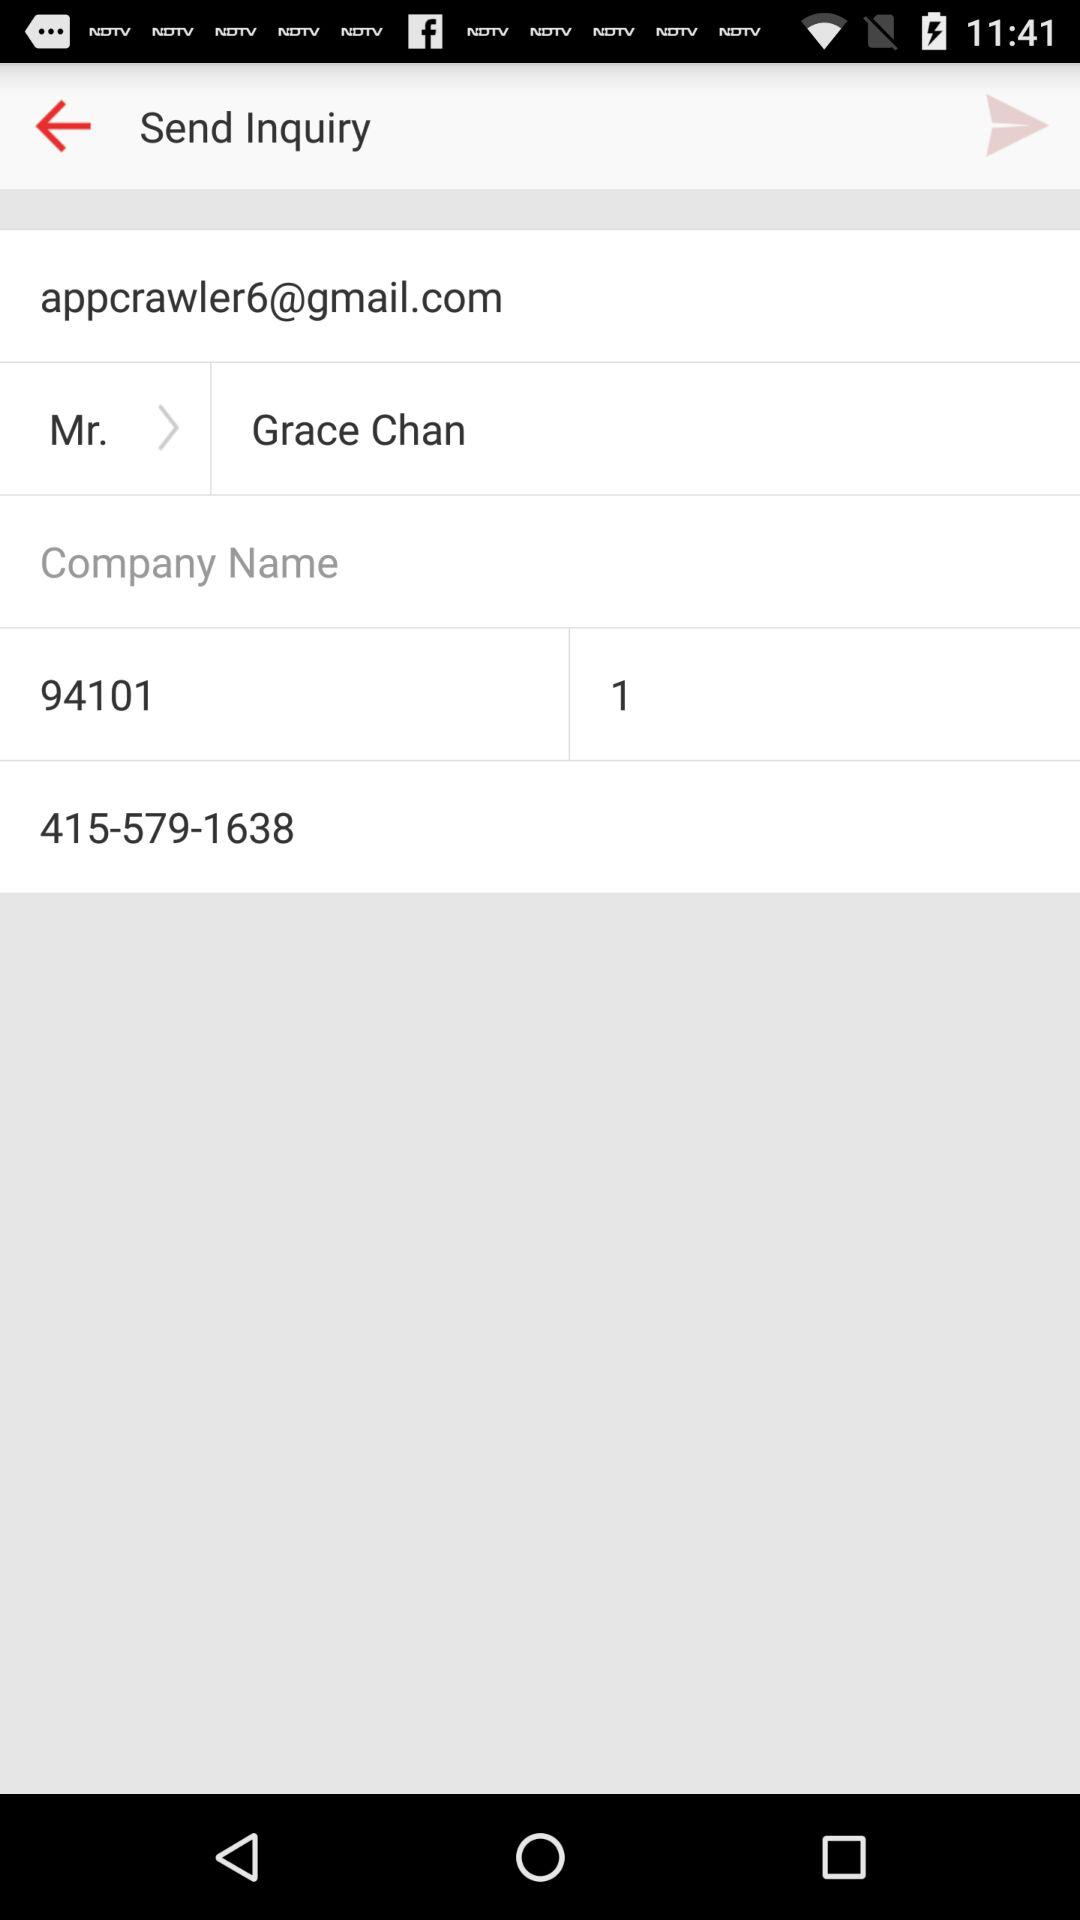How many digits are in the phone number?
Answer the question using a single word or phrase. 10 